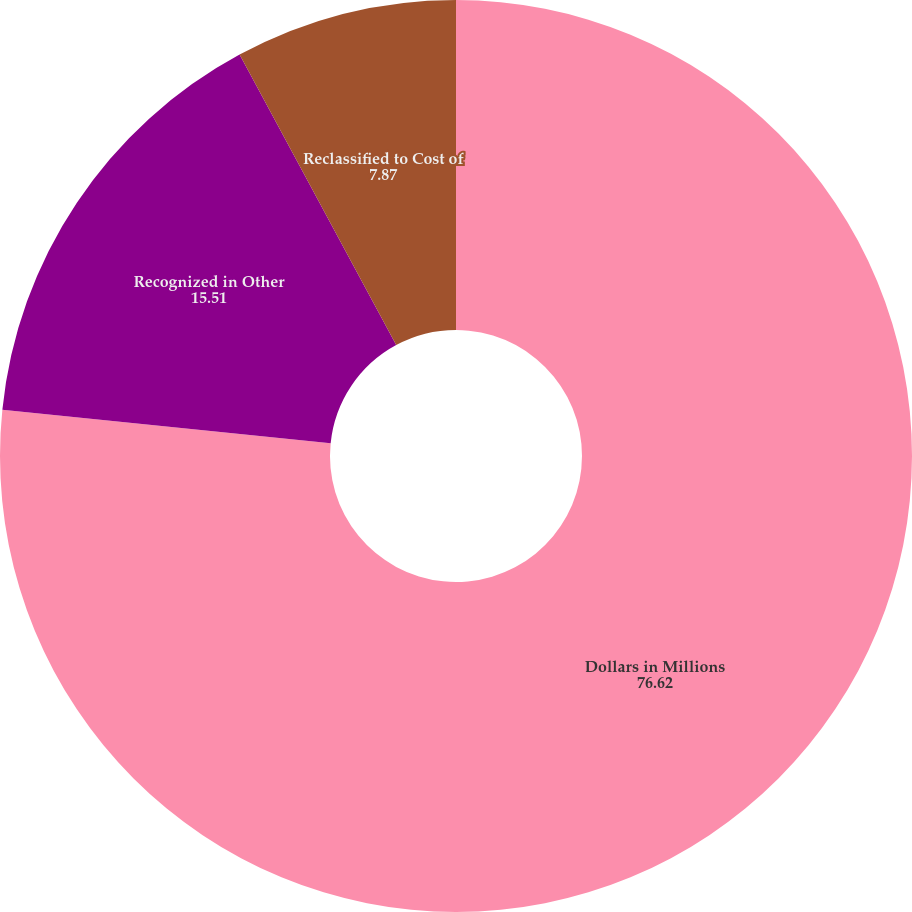Convert chart. <chart><loc_0><loc_0><loc_500><loc_500><pie_chart><fcel>Dollars in Millions<fcel>Recognized in Other<fcel>Reclassified to Cost of<nl><fcel>76.62%<fcel>15.51%<fcel>7.87%<nl></chart> 